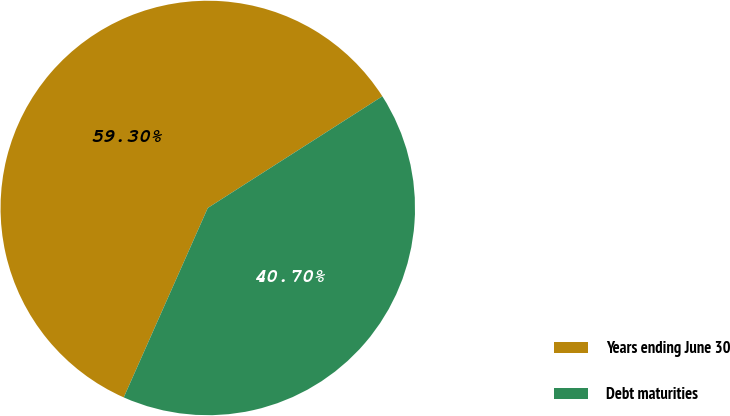Convert chart to OTSL. <chart><loc_0><loc_0><loc_500><loc_500><pie_chart><fcel>Years ending June 30<fcel>Debt maturities<nl><fcel>59.3%<fcel>40.7%<nl></chart> 